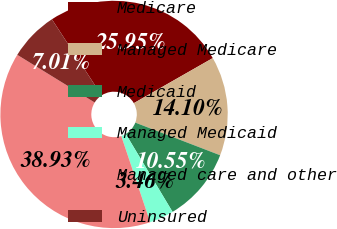<chart> <loc_0><loc_0><loc_500><loc_500><pie_chart><fcel>Medicare<fcel>Managed Medicare<fcel>Medicaid<fcel>Managed Medicaid<fcel>Managed care and other<fcel>Uninsured<nl><fcel>25.95%<fcel>14.1%<fcel>10.55%<fcel>3.46%<fcel>38.93%<fcel>7.01%<nl></chart> 